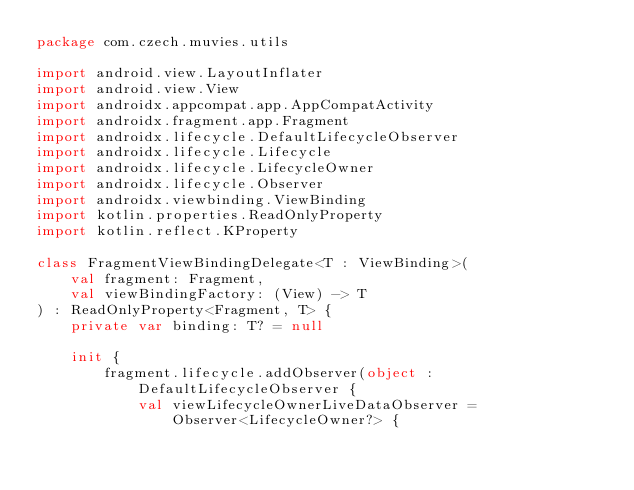<code> <loc_0><loc_0><loc_500><loc_500><_Kotlin_>package com.czech.muvies.utils

import android.view.LayoutInflater
import android.view.View
import androidx.appcompat.app.AppCompatActivity
import androidx.fragment.app.Fragment
import androidx.lifecycle.DefaultLifecycleObserver
import androidx.lifecycle.Lifecycle
import androidx.lifecycle.LifecycleOwner
import androidx.lifecycle.Observer
import androidx.viewbinding.ViewBinding
import kotlin.properties.ReadOnlyProperty
import kotlin.reflect.KProperty

class FragmentViewBindingDelegate<T : ViewBinding>(
    val fragment: Fragment,
    val viewBindingFactory: (View) -> T
) : ReadOnlyProperty<Fragment, T> {
    private var binding: T? = null

    init {
        fragment.lifecycle.addObserver(object : DefaultLifecycleObserver {
            val viewLifecycleOwnerLiveDataObserver =
                Observer<LifecycleOwner?> {</code> 